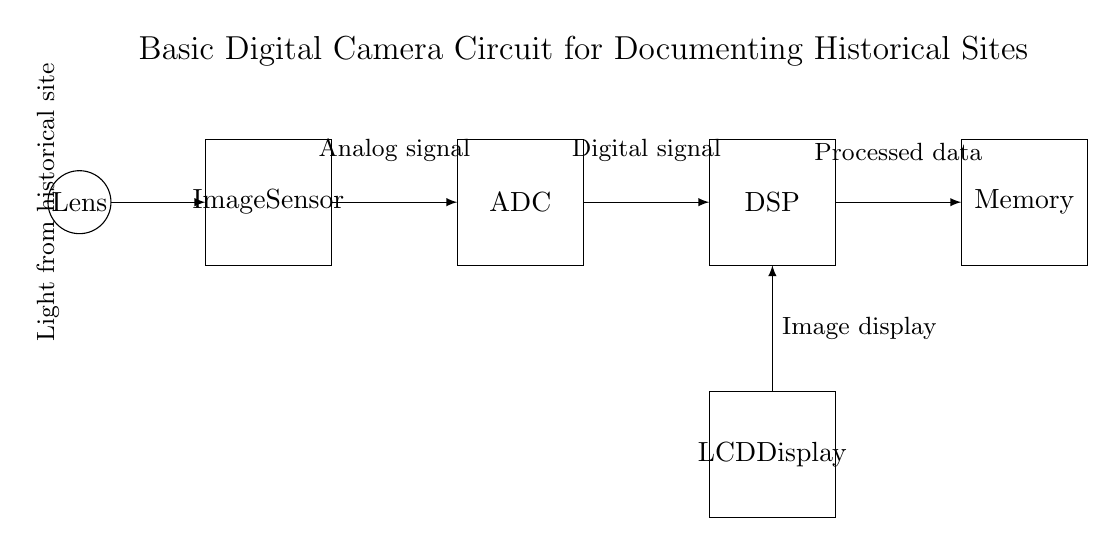What is the main function of the image sensor? The image sensor captures light from the historical site, converting it into an analog signal.
Answer: Capture light What component processes the digital signal? The Digital Signal Processor (DSP) takes the analog signal from the ADC and processes it into a digital format.
Answer: Digital Signal Processor What is the output of the ADC? The ADC converts the analog signal received from the image sensor into a digital signal for further processing.
Answer: Digital signal How is the processed data stored? The processed data from the DSP is stored in the Memory unit for future retrieval or display.
Answer: Memory What displays the final image? The final processed image is displayed on the LCD Display, which shows the captured data visually.
Answer: LCD Display What role does the lens play in this circuit? The lens focuses light from the historical site onto the image sensor, allowing for the capture of the scene.
Answer: Focus light 